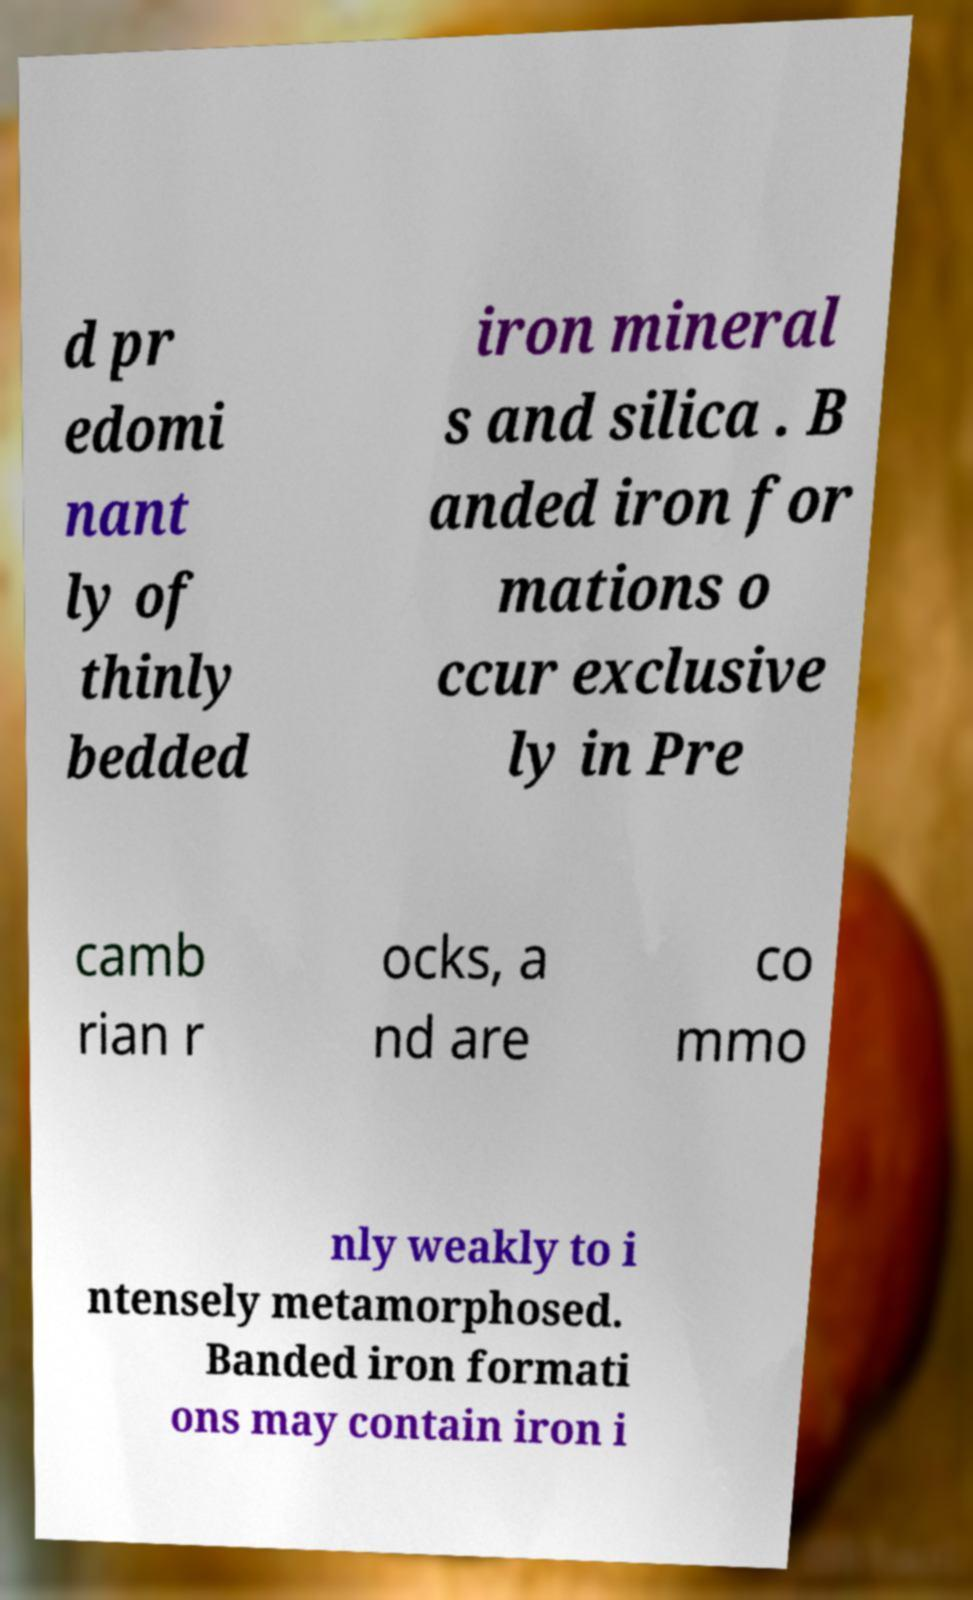I need the written content from this picture converted into text. Can you do that? d pr edomi nant ly of thinly bedded iron mineral s and silica . B anded iron for mations o ccur exclusive ly in Pre camb rian r ocks, a nd are co mmo nly weakly to i ntensely metamorphosed. Banded iron formati ons may contain iron i 